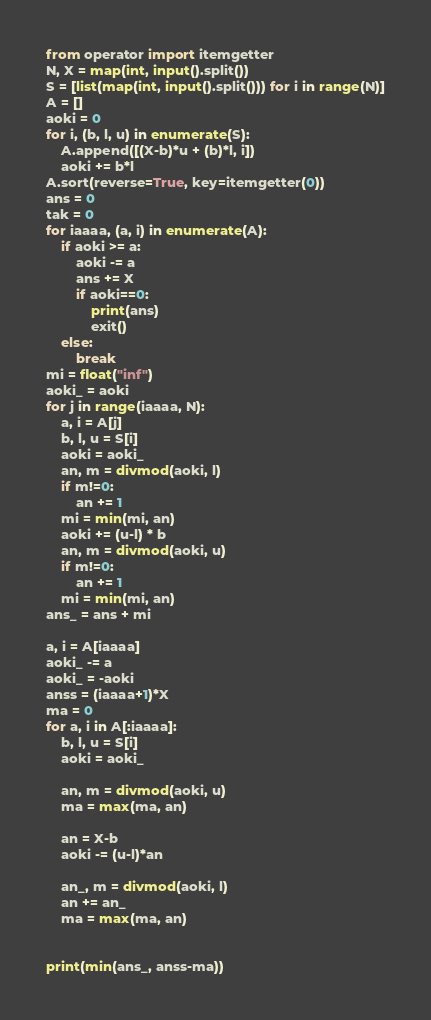Convert code to text. <code><loc_0><loc_0><loc_500><loc_500><_Python_>from operator import itemgetter
N, X = map(int, input().split())
S = [list(map(int, input().split())) for i in range(N)]
A = []
aoki = 0
for i, (b, l, u) in enumerate(S):
    A.append([(X-b)*u + (b)*l, i])
    aoki += b*l
A.sort(reverse=True, key=itemgetter(0))
ans = 0
tak = 0
for iaaaa, (a, i) in enumerate(A):
    if aoki >= a:
        aoki -= a
        ans += X
        if aoki==0:
            print(ans)
            exit()
    else:
        break
mi = float("inf")
aoki_ = aoki
for j in range(iaaaa, N):
    a, i = A[j]
    b, l, u = S[i]
    aoki = aoki_
    an, m = divmod(aoki, l)
    if m!=0:
        an += 1
    mi = min(mi, an)
    aoki += (u-l) * b
    an, m = divmod(aoki, u)
    if m!=0:
        an += 1
    mi = min(mi, an)
ans_ = ans + mi

a, i = A[iaaaa]
aoki_ -= a
aoki_ = -aoki
anss = (iaaaa+1)*X
ma = 0
for a, i in A[:iaaaa]:
    b, l, u = S[i]
    aoki = aoki_

    an, m = divmod(aoki, u)
    ma = max(ma, an)

    an = X-b
    aoki -= (u-l)*an

    an_, m = divmod(aoki, l)
    an += an_
    ma = max(ma, an)


print(min(ans_, anss-ma))
</code> 